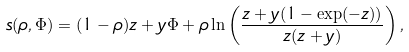<formula> <loc_0><loc_0><loc_500><loc_500>s ( \rho , \Phi ) = ( 1 - \rho ) z + y \Phi + \rho \ln \left ( \frac { z + y ( 1 - \exp ( - z ) ) } { z ( z + y ) } \right ) ,</formula> 